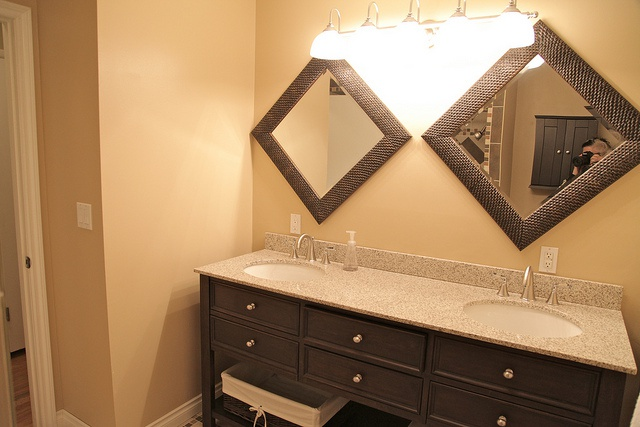Describe the objects in this image and their specific colors. I can see sink in gray and tan tones, sink in gray, tan, and beige tones, people in gray, black, brown, and maroon tones, and bottle in gray and tan tones in this image. 